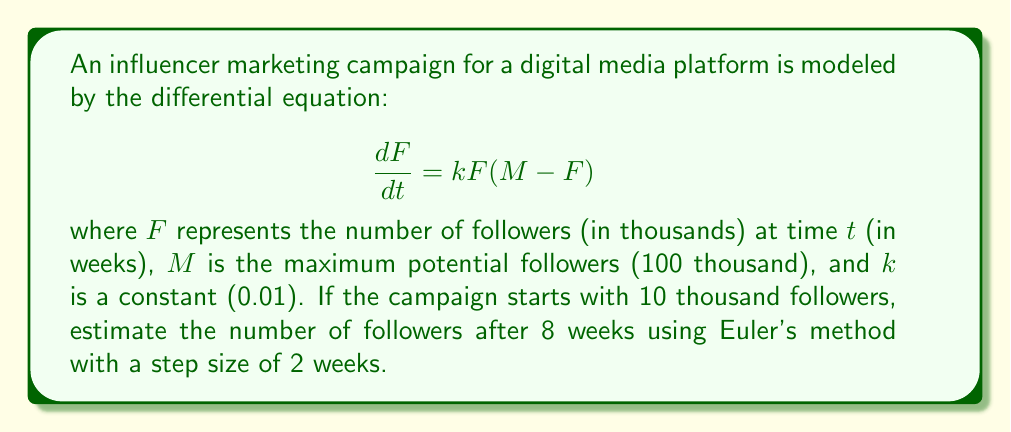Solve this math problem. 1) Euler's method is given by the formula:
   $$F_{n+1} = F_n + h \cdot f(t_n, F_n)$$
   where $h$ is the step size, and $f(t, F) = kF(M-F)$

2) Given information:
   - Initial followers: $F_0 = 10$ thousand
   - $k = 0.01$
   - $M = 100$ thousand
   - $h = 2$ weeks
   - We need to calculate for 8 weeks, so we'll use 4 steps

3) Calculate for each step:

   Step 1 (t = 0 to 2):
   $$F_1 = 10 + 2 \cdot 0.01 \cdot 10(100-10) = 10 + 18 = 28$$

   Step 2 (t = 2 to 4):
   $$F_2 = 28 + 2 \cdot 0.01 \cdot 28(100-28) = 28 + 40.32 = 68.32$$

   Step 3 (t = 4 to 6):
   $$F_3 = 68.32 + 2 \cdot 0.01 \cdot 68.32(100-68.32) = 68.32 + 43.21 = 111.53$$

   Step 4 (t = 6 to 8):
   $$F_4 = 111.53 + 2 \cdot 0.01 \cdot 111.53(100-111.53) = 111.53 - 25.78 = 85.75$$

4) The estimated number of followers after 8 weeks is 85.75 thousand.
Answer: 85.75 thousand followers 